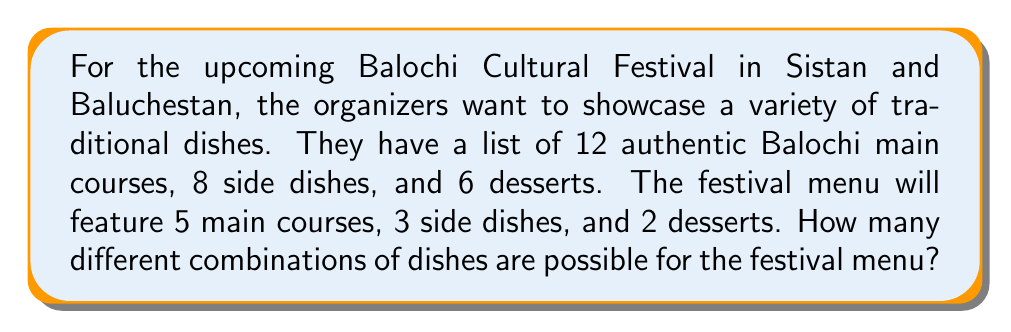Provide a solution to this math problem. To solve this problem, we need to use the combination formula for each category of dishes and then apply the multiplication principle.

1. For main courses:
   We need to choose 5 out of 12 dishes. This can be represented as $\binom{12}{5}$.
   $$\binom{12}{5} = \frac{12!}{5!(12-5)!} = \frac{12!}{5!7!} = 792$$

2. For side dishes:
   We need to choose 3 out of 8 dishes. This can be represented as $\binom{8}{3}$.
   $$\binom{8}{3} = \frac{8!}{3!(8-3)!} = \frac{8!}{3!5!} = 56$$

3. For desserts:
   We need to choose 2 out of 6 desserts. This can be represented as $\binom{6}{2}$.
   $$\binom{6}{2} = \frac{6!}{2!(6-2)!} = \frac{6!}{2!4!} = 15$$

Now, we apply the multiplication principle. Since the choices for each category are independent of each other, we multiply the number of possibilities for each category:

Total number of combinations = $792 \times 56 \times 15$

Calculating this:
$$792 \times 56 \times 15 = 665,280$$
Answer: 665,280 different combinations 